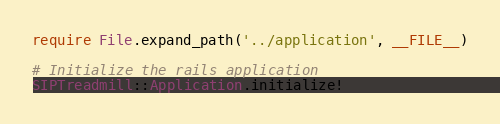Convert code to text. <code><loc_0><loc_0><loc_500><loc_500><_Ruby_>require File.expand_path('../application', __FILE__)

# Initialize the rails application
SIPTreadmill::Application.initialize!
</code> 